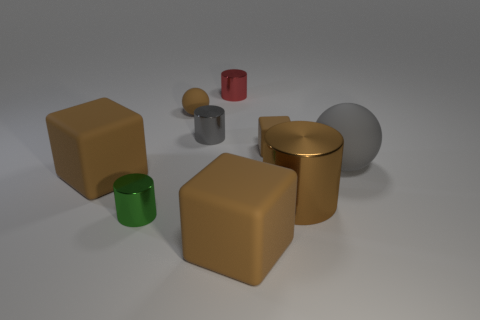There is a brown cylinder that is made of the same material as the green cylinder; what is its size?
Give a very brief answer. Large. The tiny matte block is what color?
Ensure brevity in your answer.  Brown. What number of cubes are the same color as the big cylinder?
Make the answer very short. 3. What is the material of the gray object that is the same size as the brown cylinder?
Your response must be concise. Rubber. Are there any big gray balls that are to the left of the matte object that is in front of the tiny green metal object?
Give a very brief answer. No. What number of other things are the same color as the large shiny object?
Keep it short and to the point. 4. What size is the gray cylinder?
Your answer should be compact. Small. Are there any yellow cubes?
Keep it short and to the point. No. Are there more tiny gray cylinders that are on the left side of the gray metal cylinder than big brown blocks that are in front of the large brown shiny object?
Provide a succinct answer. No. There is a big object that is both to the right of the tiny matte cube and on the left side of the big sphere; what is its material?
Provide a short and direct response. Metal. 